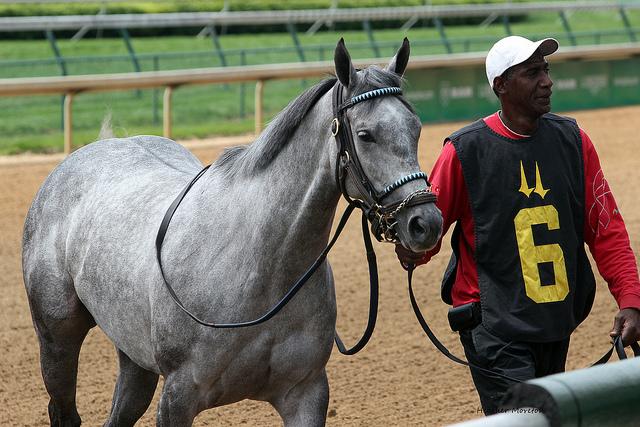Is the horse mainly brown?
Keep it brief. No. What is the color of the horse?
Write a very short answer. Gray. What color is the horse?
Short answer required. Gray. What color are the horses in this picture?
Keep it brief. Gray. Is this horse participating in a rodeo?
Quick response, please. No. Why is the horse tied?
Quick response, please. Control. What color is the horse's nose?
Write a very short answer. Gray. What color is the horse's bridle?
Answer briefly. Black. Is the man wearing a jacket?
Give a very brief answer. No. Is he wearing a helmet?
Answer briefly. No. Is the man on the horse?
Answer briefly. No. Does the horse belong to the girl?
Answer briefly. No. What color is the man's vest?
Be succinct. Black. What number is on the man's vest?
Write a very short answer. 6. 